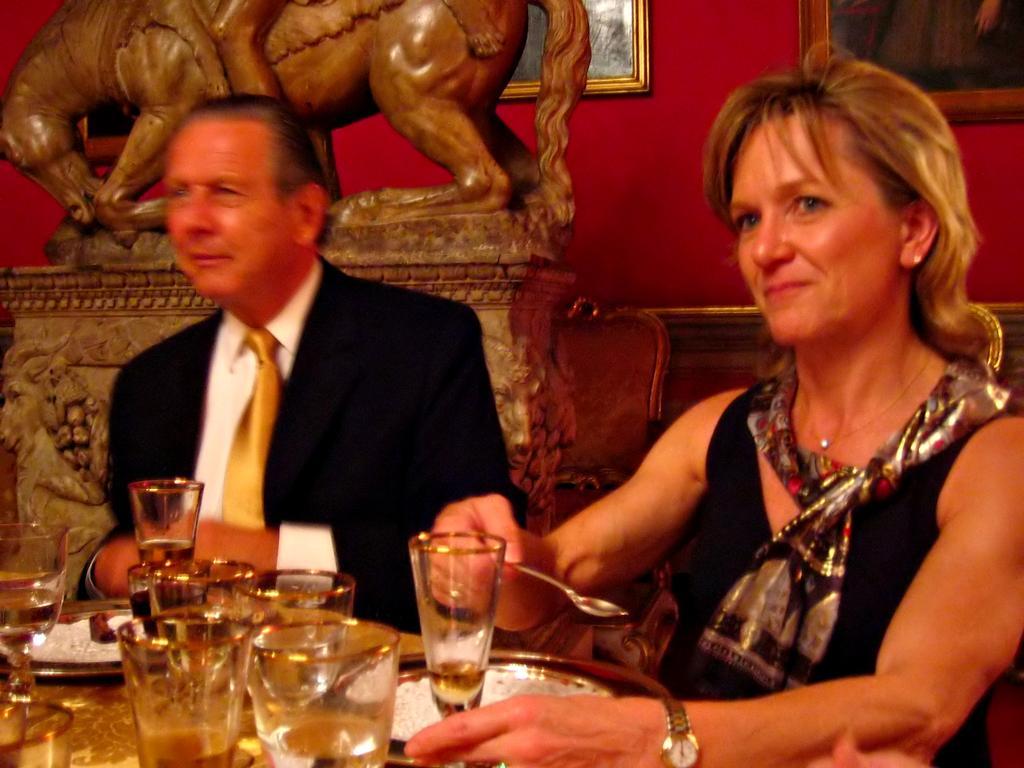Can you describe this image briefly? In this image I can see two persons and in the front of them I can see number of glasses and few plates. On the right side of this image I can see one of them is holding a spoon. In the background I can see a sculpture of an animal and few frames on the wall. 